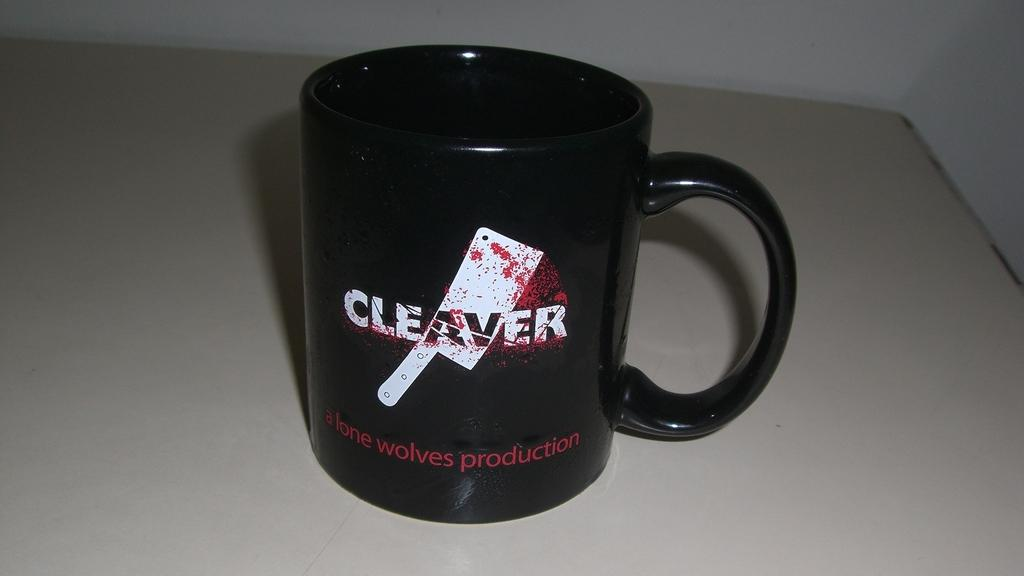<image>
Provide a brief description of the given image. A coffee cup that has a picture of a meat cleaver on it. 